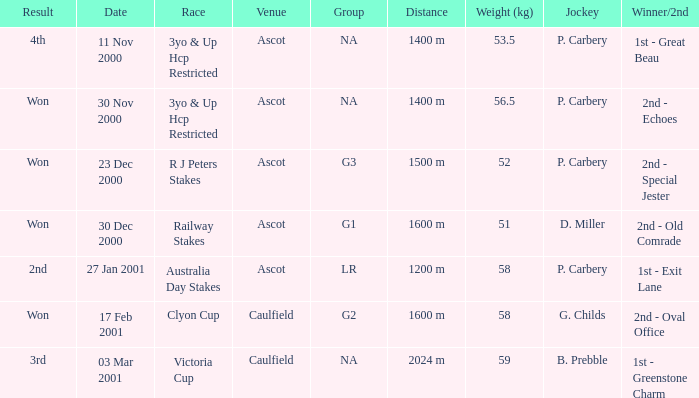What group info is available for the 56.5 kg weight? NA. Help me parse the entirety of this table. {'header': ['Result', 'Date', 'Race', 'Venue', 'Group', 'Distance', 'Weight (kg)', 'Jockey', 'Winner/2nd'], 'rows': [['4th', '11 Nov 2000', '3yo & Up Hcp Restricted', 'Ascot', 'NA', '1400 m', '53.5', 'P. Carbery', '1st - Great Beau'], ['Won', '30 Nov 2000', '3yo & Up Hcp Restricted', 'Ascot', 'NA', '1400 m', '56.5', 'P. Carbery', '2nd - Echoes'], ['Won', '23 Dec 2000', 'R J Peters Stakes', 'Ascot', 'G3', '1500 m', '52', 'P. Carbery', '2nd - Special Jester'], ['Won', '30 Dec 2000', 'Railway Stakes', 'Ascot', 'G1', '1600 m', '51', 'D. Miller', '2nd - Old Comrade'], ['2nd', '27 Jan 2001', 'Australia Day Stakes', 'Ascot', 'LR', '1200 m', '58', 'P. Carbery', '1st - Exit Lane'], ['Won', '17 Feb 2001', 'Clyon Cup', 'Caulfield', 'G2', '1600 m', '58', 'G. Childs', '2nd - Oval Office'], ['3rd', '03 Mar 2001', 'Victoria Cup', 'Caulfield', 'NA', '2024 m', '59', 'B. Prebble', '1st - Greenstone Charm']]} 